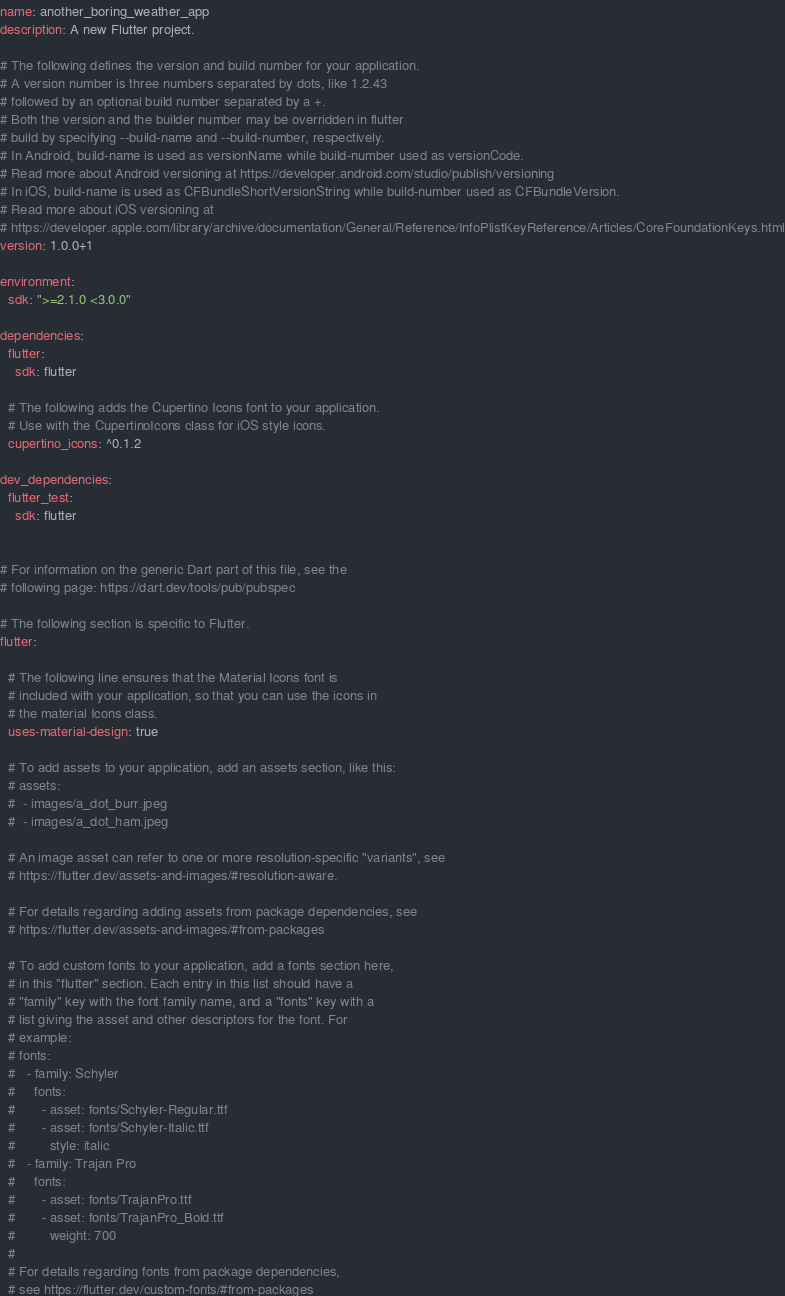<code> <loc_0><loc_0><loc_500><loc_500><_YAML_>name: another_boring_weather_app
description: A new Flutter project.

# The following defines the version and build number for your application.
# A version number is three numbers separated by dots, like 1.2.43
# followed by an optional build number separated by a +.
# Both the version and the builder number may be overridden in flutter
# build by specifying --build-name and --build-number, respectively.
# In Android, build-name is used as versionName while build-number used as versionCode.
# Read more about Android versioning at https://developer.android.com/studio/publish/versioning
# In iOS, build-name is used as CFBundleShortVersionString while build-number used as CFBundleVersion.
# Read more about iOS versioning at
# https://developer.apple.com/library/archive/documentation/General/Reference/InfoPlistKeyReference/Articles/CoreFoundationKeys.html
version: 1.0.0+1

environment:
  sdk: ">=2.1.0 <3.0.0"

dependencies:
  flutter:
    sdk: flutter

  # The following adds the Cupertino Icons font to your application.
  # Use with the CupertinoIcons class for iOS style icons.
  cupertino_icons: ^0.1.2

dev_dependencies:
  flutter_test:
    sdk: flutter


# For information on the generic Dart part of this file, see the
# following page: https://dart.dev/tools/pub/pubspec

# The following section is specific to Flutter.
flutter:

  # The following line ensures that the Material Icons font is
  # included with your application, so that you can use the icons in
  # the material Icons class.
  uses-material-design: true

  # To add assets to your application, add an assets section, like this:
  # assets:
  #  - images/a_dot_burr.jpeg
  #  - images/a_dot_ham.jpeg

  # An image asset can refer to one or more resolution-specific "variants", see
  # https://flutter.dev/assets-and-images/#resolution-aware.

  # For details regarding adding assets from package dependencies, see
  # https://flutter.dev/assets-and-images/#from-packages

  # To add custom fonts to your application, add a fonts section here,
  # in this "flutter" section. Each entry in this list should have a
  # "family" key with the font family name, and a "fonts" key with a
  # list giving the asset and other descriptors for the font. For
  # example:
  # fonts:
  #   - family: Schyler
  #     fonts:
  #       - asset: fonts/Schyler-Regular.ttf
  #       - asset: fonts/Schyler-Italic.ttf
  #         style: italic
  #   - family: Trajan Pro
  #     fonts:
  #       - asset: fonts/TrajanPro.ttf
  #       - asset: fonts/TrajanPro_Bold.ttf
  #         weight: 700
  #
  # For details regarding fonts from package dependencies,
  # see https://flutter.dev/custom-fonts/#from-packages
</code> 